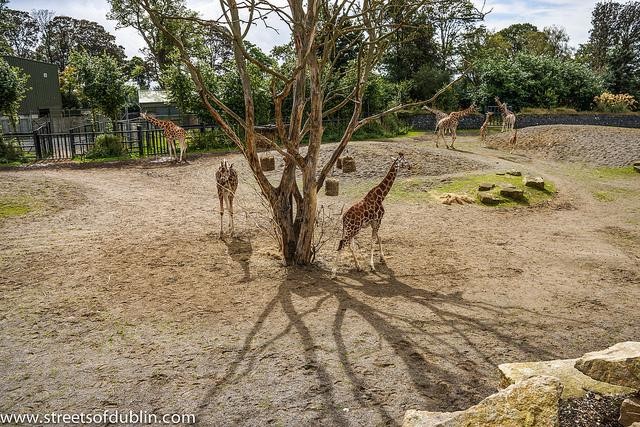What are the giraffes near? Please explain your reasoning. trees. The giraffes are standing around a couple of trees in the zoo pen. 